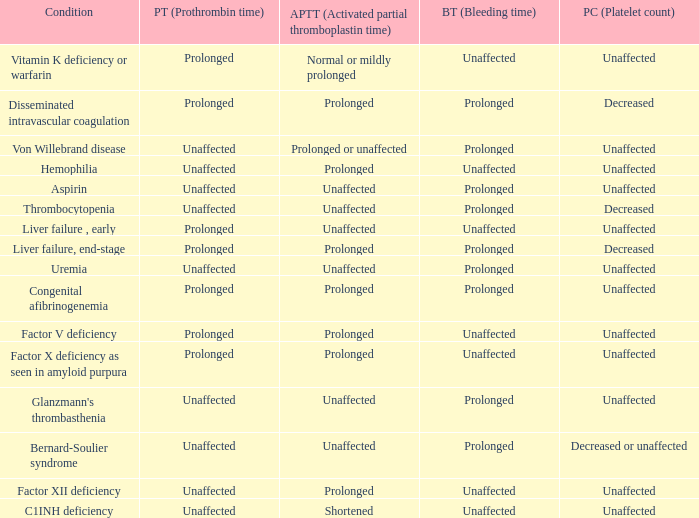Which Condition has a Bleeding time of unaffected, and a Partial thromboplastin time of prolonged, and a Prothrombin time of unaffected? Hemophilia, Factor XII deficiency. 